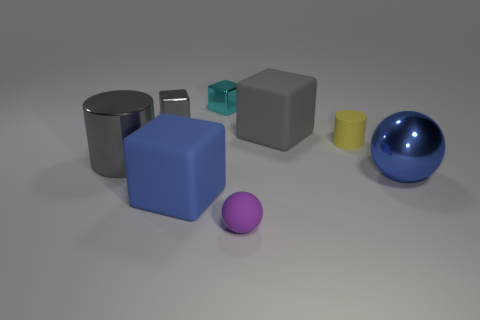Add 2 small cyan metallic objects. How many objects exist? 10 Subtract all blue cubes. How many cubes are left? 3 Subtract all gray cylinders. How many cylinders are left? 1 Subtract 2 spheres. How many spheres are left? 0 Subtract all spheres. How many objects are left? 6 Subtract all gray balls. Subtract all yellow cylinders. How many balls are left? 2 Subtract all red balls. How many yellow cylinders are left? 1 Subtract all brown metal cylinders. Subtract all blue blocks. How many objects are left? 7 Add 4 large blue balls. How many large blue balls are left? 5 Add 4 big gray matte things. How many big gray matte things exist? 5 